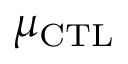<formula> <loc_0><loc_0><loc_500><loc_500>\mu _ { C T L }</formula> 